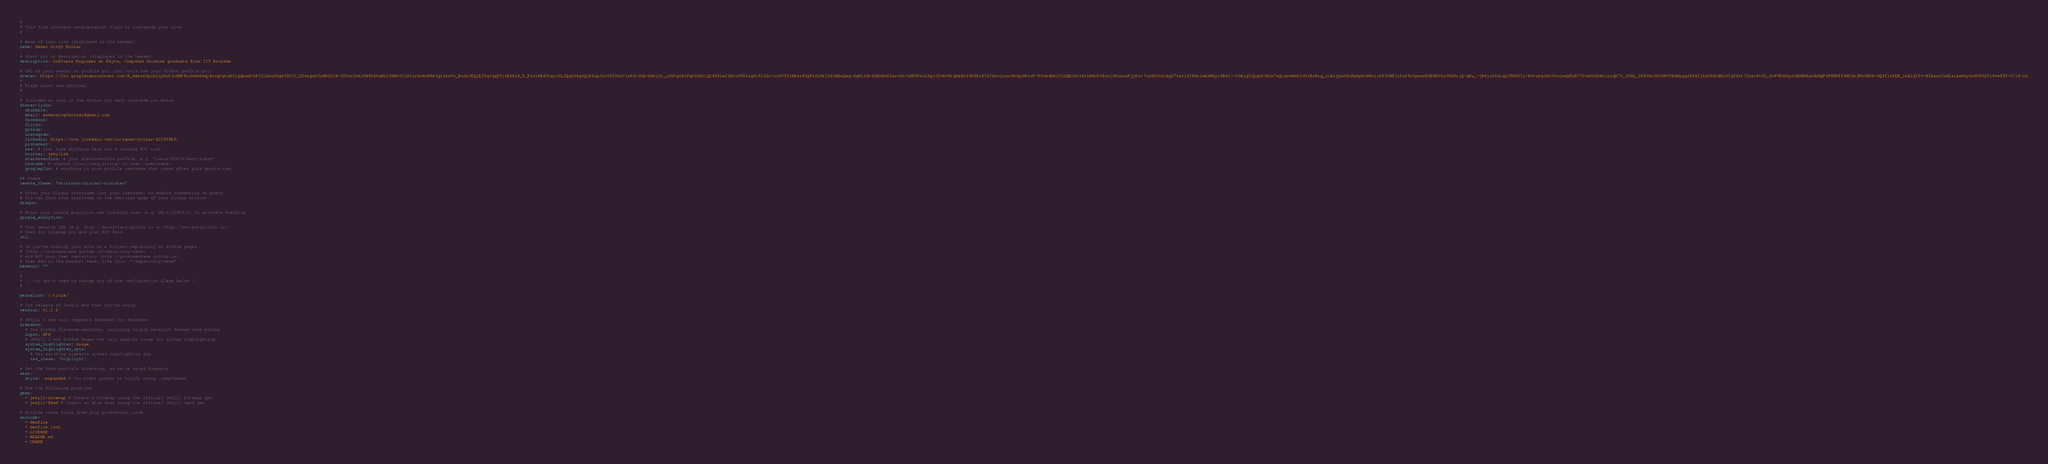<code> <loc_0><loc_0><loc_500><loc_500><_YAML_>#
# This file contains configuration flags to customize your site
#

# Name of your site (displayed in the header)
name: Samar Singh Holkar

# Short bio or description (displayed in the header)
description: Software Engineer at Paytm, Computer Science graduate from IIT Roorkee

# URL of your avatar or profile pic (you could use your GitHub profile pic)
avatar: https://lh3.googleusercontent.com/N_Hsbs4Zpub2oyKufJuKBF8ioh9m5mqy6ncQtgtaH3lgQmxdVrP0lLGxoOdgeTGUIC_U3sxgxGJuNRU0lB-TXVxv2wXr5W9hEkaWzI3MRkUVLXhizhwNzW6eTgzJssVw_BonbJEQjE05qvqq50jfEdFa9_8_FzviPA4Chay1XL3QgGX4qwQyE4LpJuvO50ImrVitP6iYhA-MdkiCr_uSGOgUmI9qOSSAh1QC9D5Le2YRtu595logXv6lh3c-iw3V091NR4r8IQF4fzMtISScAEmQeq-SqRl3dtdjBhMwS3aoc4h-LNR0Fkn1hpjCOvbVRtQDeBJz9K6Ec9TrVGxnjsxnJHvQuXPooF-P0vmdbR1VyZQNJaYr8tLRNcPU8nrjXPuwrxFjyFzt7cp9XUnkiHgG7tat1fY6No1mAXWRyrSBs2--tOAjq32pgbK3Rkm7aQcqweMmK3vU1Ea5zg_c1A1jpuO9uEeNpGr8Wo1iD63UHPTi0xf6LOpwmrE8PWKULsTNd6zjQ-qNu_-jR8juk9sLqzJ5RNYly-WJvxKgcNt0OooreQ8b8C7OvsKXdbHnlniqK7S_IOMy_ZPfUKn3HINWVCBMMpgqcWf4fjkpX5WLBHw3TgX4Zz72bsc9vd3_GcFVEkNqckKBHRWuedhRQFkFW6KFf4WCfx3FbCBPW-GQ4TlzXEB_1mA2qTfv-BTAaxrTxHLslaeRGyknMVfkK516=w955-h716-no
#
# Flags below are optional
#

# Includes an icon in the footer for each username you enter
footer-links:
  dribbble:
  email: samarsinghholkar@gmail.com
  facebook:
  flickr:
  github: 
  instagram: 
  linkedin: https://www.linkedin.com/in/samar-holkar-422906b5/
  pinterest:
  rss: # just type anything here for a working RSS icon
  twitter: jekyllrb
  stackoverflow: # your stackoverflow profile, e.g. "users/50476/bart-kiers"
  youtube: # channel/<your_long_string> or user/<user-name>
  googleplus: # anything in your profile username that comes after plus.google.com/

## theme
remote_theme: "mmistakes/minimal-mistakes"

# Enter your Disqus shortname (not your username) to enable commenting on posts
# You can find your shortname on the Settings page of your Disqus account
disqus:

# Enter your Google Analytics web tracking code (e.g. UA-2110908-2) to activate tracking
google_analytics:

# Your website URL (e.g. http://barryclark.github.io or http://www.barryclark.co)
# Used for Sitemap.xml and your RSS feed
url:

# If you're hosting your site at a Project repository on GitHub pages
# (http://yourusername.github.io/repository-name)
# and NOT your User repository (http://yourusername.github.io)
# then add in the baseurl here, like this: "/repository-name"
baseurl: ""

#
# !! You don't need to change any of the configuration flags below !!
#

permalink: /:title/

# The release of Jekyll Now that you're using
version: v1.2.0

# Jekyll 3 now only supports Kramdown for Markdown
kramdown:
  # Use GitHub flavored markdown, including triple backtick fenced code blocks
  input: GFM
  # Jekyll 3 and GitHub Pages now only support rouge for syntax highlighting
  syntax_highlighter: rouge
  syntax_highlighter_opts:
    # Use existing pygments syntax highlighting css
    css_class: 'highlight'

# Set the Sass partials directory, as we're using @imports
sass:
  style: :expanded # You might prefer to minify using :compressed

# Use the following plug-ins
gems:
  - jekyll-sitemap # Create a sitemap using the official Jekyll sitemap gem
  - jekyll-feed # Create an Atom feed using the official Jekyll feed gem

# Exclude these files from your production _site
exclude:
  - Gemfile
  - Gemfile.lock
  - LICENSE
  - README.md
  - CNAME
</code> 